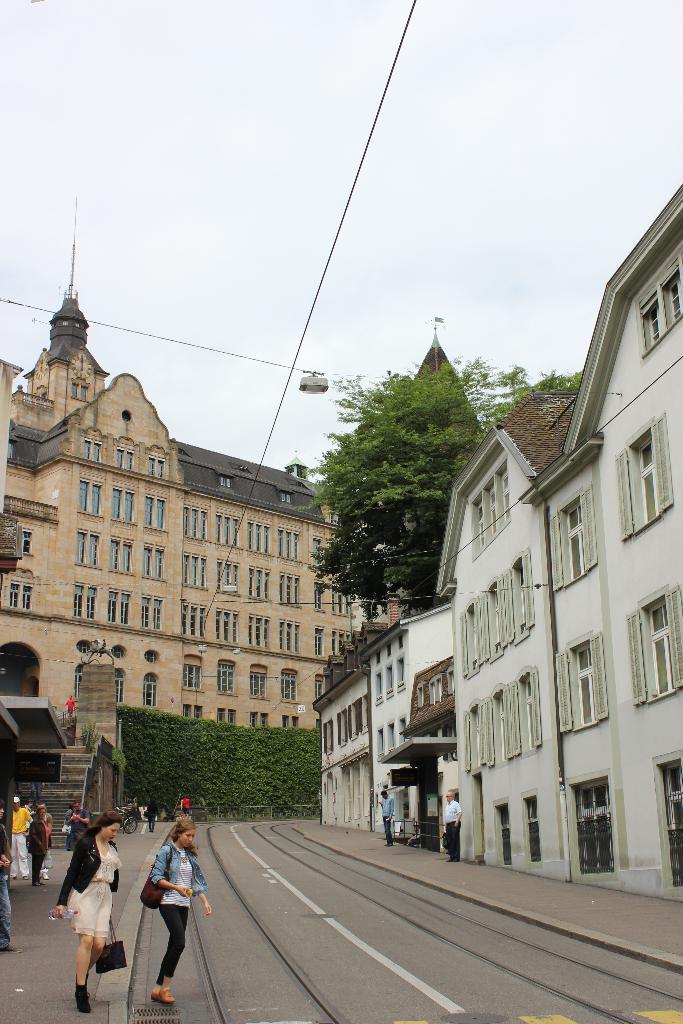How would you summarize this image in a sentence or two? In the image we can see buildings and these are the windows of the buildings. We can even see there are people walking and some of them are standing. They are wearing clothes and shoes. Here we can see train tracks, stairs, electric wires, trees, plants and the sky. 